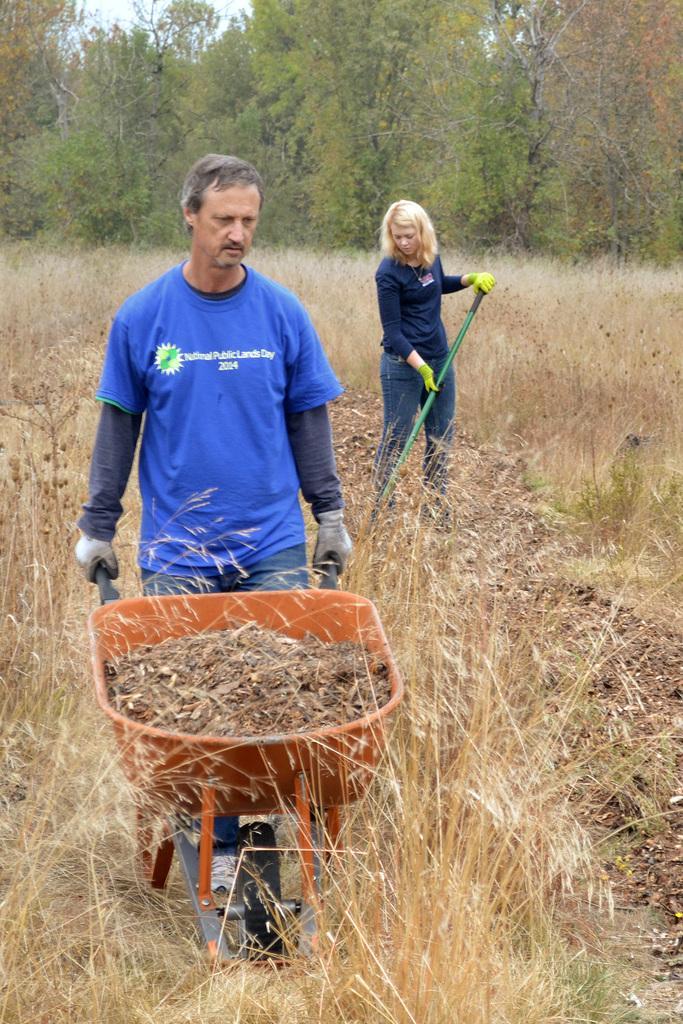Could you give a brief overview of what you see in this image? In this picture I can see there is a man holding a trolley and moving it. The woman in the backdrop is holding a stick and there is grass and trees in the backdrop. 